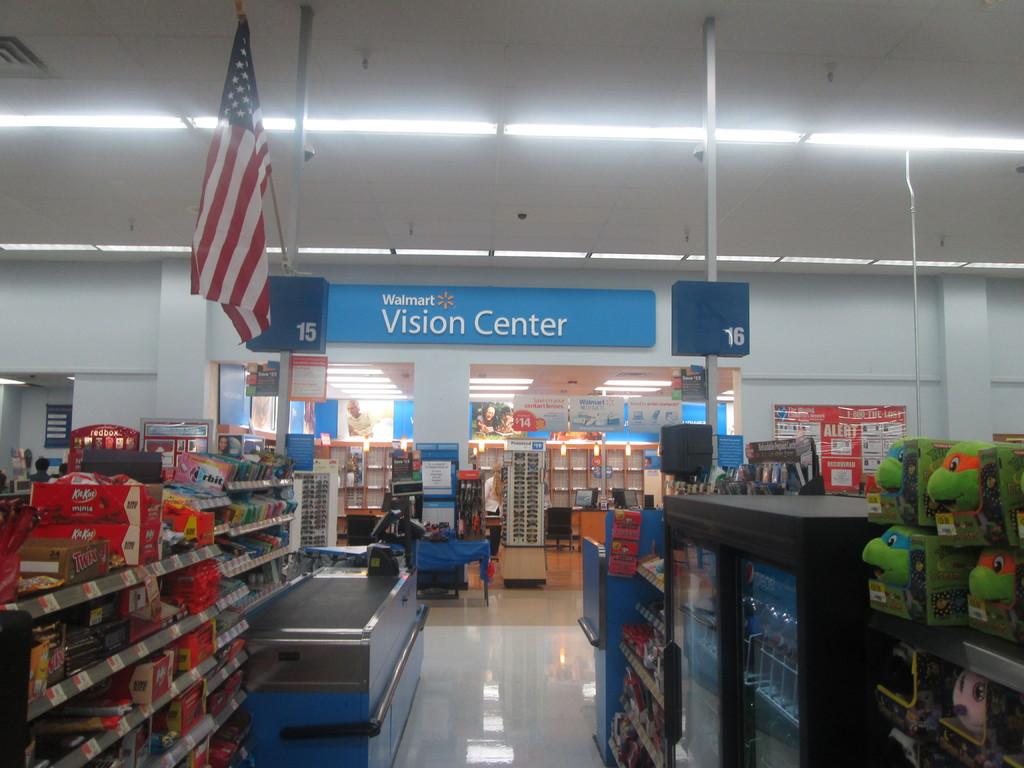Which cashier number is on the left?
Make the answer very short. 15. 